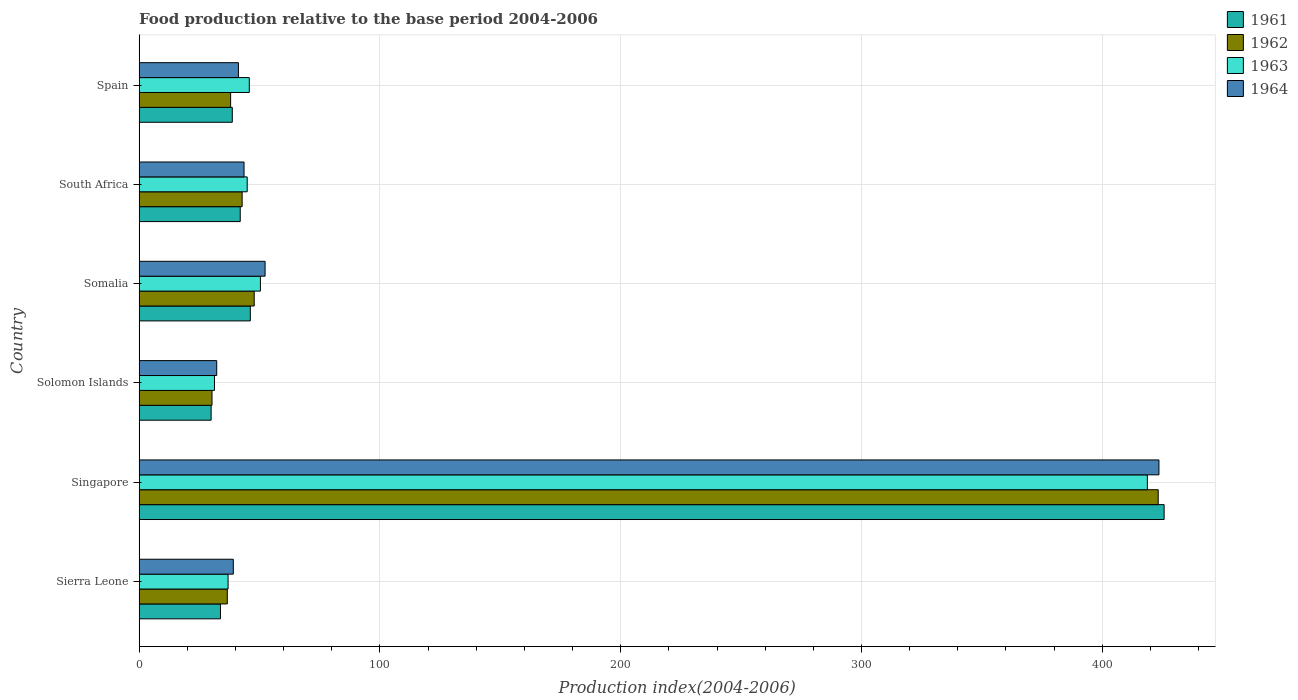How many groups of bars are there?
Provide a succinct answer. 6. How many bars are there on the 1st tick from the top?
Your response must be concise. 4. What is the label of the 3rd group of bars from the top?
Keep it short and to the point. Somalia. What is the food production index in 1964 in Sierra Leone?
Give a very brief answer. 39.1. Across all countries, what is the maximum food production index in 1961?
Make the answer very short. 425.69. Across all countries, what is the minimum food production index in 1963?
Offer a very short reply. 31.28. In which country was the food production index in 1964 maximum?
Your response must be concise. Singapore. In which country was the food production index in 1963 minimum?
Your answer should be very brief. Solomon Islands. What is the total food production index in 1964 in the graph?
Your response must be concise. 631.94. What is the difference between the food production index in 1962 in Sierra Leone and that in South Africa?
Your response must be concise. -6.16. What is the difference between the food production index in 1962 in Sierra Leone and the food production index in 1964 in Solomon Islands?
Keep it short and to the point. 4.4. What is the average food production index in 1963 per country?
Provide a succinct answer. 104.65. What is the difference between the food production index in 1961 and food production index in 1962 in Sierra Leone?
Keep it short and to the point. -2.85. What is the ratio of the food production index in 1963 in Solomon Islands to that in Somalia?
Your answer should be very brief. 0.62. Is the food production index in 1962 in Somalia less than that in South Africa?
Your answer should be compact. No. What is the difference between the highest and the second highest food production index in 1963?
Make the answer very short. 368.37. What is the difference between the highest and the lowest food production index in 1963?
Your answer should be very brief. 387.45. In how many countries, is the food production index in 1962 greater than the average food production index in 1962 taken over all countries?
Ensure brevity in your answer.  1. Is the sum of the food production index in 1964 in Sierra Leone and Solomon Islands greater than the maximum food production index in 1961 across all countries?
Make the answer very short. No. What does the 1st bar from the top in Somalia represents?
Your answer should be very brief. 1964. What does the 3rd bar from the bottom in Spain represents?
Provide a short and direct response. 1963. Is it the case that in every country, the sum of the food production index in 1964 and food production index in 1963 is greater than the food production index in 1961?
Offer a terse response. Yes. Are all the bars in the graph horizontal?
Your response must be concise. Yes. How many countries are there in the graph?
Your answer should be compact. 6. What is the difference between two consecutive major ticks on the X-axis?
Keep it short and to the point. 100. Are the values on the major ticks of X-axis written in scientific E-notation?
Your answer should be compact. No. Does the graph contain any zero values?
Make the answer very short. No. How many legend labels are there?
Make the answer very short. 4. What is the title of the graph?
Provide a short and direct response. Food production relative to the base period 2004-2006. What is the label or title of the X-axis?
Your answer should be very brief. Production index(2004-2006). What is the label or title of the Y-axis?
Give a very brief answer. Country. What is the Production index(2004-2006) of 1961 in Sierra Leone?
Ensure brevity in your answer.  33.76. What is the Production index(2004-2006) in 1962 in Sierra Leone?
Your response must be concise. 36.61. What is the Production index(2004-2006) in 1963 in Sierra Leone?
Provide a succinct answer. 36.93. What is the Production index(2004-2006) in 1964 in Sierra Leone?
Your answer should be compact. 39.1. What is the Production index(2004-2006) in 1961 in Singapore?
Keep it short and to the point. 425.69. What is the Production index(2004-2006) in 1962 in Singapore?
Offer a very short reply. 423.23. What is the Production index(2004-2006) in 1963 in Singapore?
Give a very brief answer. 418.73. What is the Production index(2004-2006) of 1964 in Singapore?
Offer a very short reply. 423.54. What is the Production index(2004-2006) of 1961 in Solomon Islands?
Make the answer very short. 29.89. What is the Production index(2004-2006) of 1962 in Solomon Islands?
Give a very brief answer. 30.26. What is the Production index(2004-2006) in 1963 in Solomon Islands?
Make the answer very short. 31.28. What is the Production index(2004-2006) in 1964 in Solomon Islands?
Your response must be concise. 32.21. What is the Production index(2004-2006) in 1961 in Somalia?
Your response must be concise. 46.17. What is the Production index(2004-2006) in 1962 in Somalia?
Make the answer very short. 47.78. What is the Production index(2004-2006) in 1963 in Somalia?
Make the answer very short. 50.36. What is the Production index(2004-2006) in 1964 in Somalia?
Give a very brief answer. 52.3. What is the Production index(2004-2006) in 1961 in South Africa?
Ensure brevity in your answer.  41.98. What is the Production index(2004-2006) of 1962 in South Africa?
Ensure brevity in your answer.  42.77. What is the Production index(2004-2006) of 1963 in South Africa?
Your response must be concise. 44.87. What is the Production index(2004-2006) of 1964 in South Africa?
Ensure brevity in your answer.  43.56. What is the Production index(2004-2006) of 1961 in Spain?
Your answer should be very brief. 38.68. What is the Production index(2004-2006) in 1962 in Spain?
Provide a short and direct response. 37.99. What is the Production index(2004-2006) in 1963 in Spain?
Ensure brevity in your answer.  45.74. What is the Production index(2004-2006) of 1964 in Spain?
Your answer should be very brief. 41.23. Across all countries, what is the maximum Production index(2004-2006) of 1961?
Provide a succinct answer. 425.69. Across all countries, what is the maximum Production index(2004-2006) in 1962?
Ensure brevity in your answer.  423.23. Across all countries, what is the maximum Production index(2004-2006) in 1963?
Offer a very short reply. 418.73. Across all countries, what is the maximum Production index(2004-2006) in 1964?
Give a very brief answer. 423.54. Across all countries, what is the minimum Production index(2004-2006) in 1961?
Your response must be concise. 29.89. Across all countries, what is the minimum Production index(2004-2006) in 1962?
Your response must be concise. 30.26. Across all countries, what is the minimum Production index(2004-2006) in 1963?
Ensure brevity in your answer.  31.28. Across all countries, what is the minimum Production index(2004-2006) in 1964?
Provide a short and direct response. 32.21. What is the total Production index(2004-2006) of 1961 in the graph?
Give a very brief answer. 616.17. What is the total Production index(2004-2006) in 1962 in the graph?
Offer a very short reply. 618.64. What is the total Production index(2004-2006) of 1963 in the graph?
Your answer should be compact. 627.91. What is the total Production index(2004-2006) of 1964 in the graph?
Give a very brief answer. 631.94. What is the difference between the Production index(2004-2006) of 1961 in Sierra Leone and that in Singapore?
Your answer should be compact. -391.93. What is the difference between the Production index(2004-2006) in 1962 in Sierra Leone and that in Singapore?
Ensure brevity in your answer.  -386.62. What is the difference between the Production index(2004-2006) of 1963 in Sierra Leone and that in Singapore?
Your response must be concise. -381.8. What is the difference between the Production index(2004-2006) in 1964 in Sierra Leone and that in Singapore?
Your response must be concise. -384.44. What is the difference between the Production index(2004-2006) of 1961 in Sierra Leone and that in Solomon Islands?
Provide a succinct answer. 3.87. What is the difference between the Production index(2004-2006) in 1962 in Sierra Leone and that in Solomon Islands?
Your answer should be very brief. 6.35. What is the difference between the Production index(2004-2006) in 1963 in Sierra Leone and that in Solomon Islands?
Offer a terse response. 5.65. What is the difference between the Production index(2004-2006) in 1964 in Sierra Leone and that in Solomon Islands?
Ensure brevity in your answer.  6.89. What is the difference between the Production index(2004-2006) in 1961 in Sierra Leone and that in Somalia?
Give a very brief answer. -12.41. What is the difference between the Production index(2004-2006) of 1962 in Sierra Leone and that in Somalia?
Keep it short and to the point. -11.17. What is the difference between the Production index(2004-2006) in 1963 in Sierra Leone and that in Somalia?
Provide a short and direct response. -13.43. What is the difference between the Production index(2004-2006) in 1964 in Sierra Leone and that in Somalia?
Your response must be concise. -13.2. What is the difference between the Production index(2004-2006) in 1961 in Sierra Leone and that in South Africa?
Your response must be concise. -8.22. What is the difference between the Production index(2004-2006) in 1962 in Sierra Leone and that in South Africa?
Your answer should be compact. -6.16. What is the difference between the Production index(2004-2006) of 1963 in Sierra Leone and that in South Africa?
Give a very brief answer. -7.94. What is the difference between the Production index(2004-2006) of 1964 in Sierra Leone and that in South Africa?
Your response must be concise. -4.46. What is the difference between the Production index(2004-2006) in 1961 in Sierra Leone and that in Spain?
Keep it short and to the point. -4.92. What is the difference between the Production index(2004-2006) of 1962 in Sierra Leone and that in Spain?
Your answer should be compact. -1.38. What is the difference between the Production index(2004-2006) of 1963 in Sierra Leone and that in Spain?
Keep it short and to the point. -8.81. What is the difference between the Production index(2004-2006) in 1964 in Sierra Leone and that in Spain?
Ensure brevity in your answer.  -2.13. What is the difference between the Production index(2004-2006) of 1961 in Singapore and that in Solomon Islands?
Your response must be concise. 395.8. What is the difference between the Production index(2004-2006) of 1962 in Singapore and that in Solomon Islands?
Offer a very short reply. 392.97. What is the difference between the Production index(2004-2006) in 1963 in Singapore and that in Solomon Islands?
Offer a terse response. 387.45. What is the difference between the Production index(2004-2006) of 1964 in Singapore and that in Solomon Islands?
Give a very brief answer. 391.33. What is the difference between the Production index(2004-2006) of 1961 in Singapore and that in Somalia?
Keep it short and to the point. 379.52. What is the difference between the Production index(2004-2006) in 1962 in Singapore and that in Somalia?
Provide a short and direct response. 375.45. What is the difference between the Production index(2004-2006) of 1963 in Singapore and that in Somalia?
Your response must be concise. 368.37. What is the difference between the Production index(2004-2006) of 1964 in Singapore and that in Somalia?
Make the answer very short. 371.24. What is the difference between the Production index(2004-2006) in 1961 in Singapore and that in South Africa?
Keep it short and to the point. 383.71. What is the difference between the Production index(2004-2006) of 1962 in Singapore and that in South Africa?
Offer a very short reply. 380.46. What is the difference between the Production index(2004-2006) in 1963 in Singapore and that in South Africa?
Give a very brief answer. 373.86. What is the difference between the Production index(2004-2006) of 1964 in Singapore and that in South Africa?
Ensure brevity in your answer.  379.98. What is the difference between the Production index(2004-2006) of 1961 in Singapore and that in Spain?
Make the answer very short. 387.01. What is the difference between the Production index(2004-2006) in 1962 in Singapore and that in Spain?
Give a very brief answer. 385.24. What is the difference between the Production index(2004-2006) in 1963 in Singapore and that in Spain?
Ensure brevity in your answer.  372.99. What is the difference between the Production index(2004-2006) in 1964 in Singapore and that in Spain?
Keep it short and to the point. 382.31. What is the difference between the Production index(2004-2006) of 1961 in Solomon Islands and that in Somalia?
Give a very brief answer. -16.28. What is the difference between the Production index(2004-2006) in 1962 in Solomon Islands and that in Somalia?
Provide a succinct answer. -17.52. What is the difference between the Production index(2004-2006) in 1963 in Solomon Islands and that in Somalia?
Your answer should be very brief. -19.08. What is the difference between the Production index(2004-2006) in 1964 in Solomon Islands and that in Somalia?
Give a very brief answer. -20.09. What is the difference between the Production index(2004-2006) of 1961 in Solomon Islands and that in South Africa?
Ensure brevity in your answer.  -12.09. What is the difference between the Production index(2004-2006) in 1962 in Solomon Islands and that in South Africa?
Ensure brevity in your answer.  -12.51. What is the difference between the Production index(2004-2006) of 1963 in Solomon Islands and that in South Africa?
Ensure brevity in your answer.  -13.59. What is the difference between the Production index(2004-2006) in 1964 in Solomon Islands and that in South Africa?
Keep it short and to the point. -11.35. What is the difference between the Production index(2004-2006) in 1961 in Solomon Islands and that in Spain?
Make the answer very short. -8.79. What is the difference between the Production index(2004-2006) of 1962 in Solomon Islands and that in Spain?
Offer a very short reply. -7.73. What is the difference between the Production index(2004-2006) in 1963 in Solomon Islands and that in Spain?
Your answer should be very brief. -14.46. What is the difference between the Production index(2004-2006) of 1964 in Solomon Islands and that in Spain?
Make the answer very short. -9.02. What is the difference between the Production index(2004-2006) of 1961 in Somalia and that in South Africa?
Offer a very short reply. 4.19. What is the difference between the Production index(2004-2006) in 1962 in Somalia and that in South Africa?
Make the answer very short. 5.01. What is the difference between the Production index(2004-2006) in 1963 in Somalia and that in South Africa?
Offer a terse response. 5.49. What is the difference between the Production index(2004-2006) of 1964 in Somalia and that in South Africa?
Offer a very short reply. 8.74. What is the difference between the Production index(2004-2006) of 1961 in Somalia and that in Spain?
Ensure brevity in your answer.  7.49. What is the difference between the Production index(2004-2006) in 1962 in Somalia and that in Spain?
Offer a very short reply. 9.79. What is the difference between the Production index(2004-2006) in 1963 in Somalia and that in Spain?
Give a very brief answer. 4.62. What is the difference between the Production index(2004-2006) in 1964 in Somalia and that in Spain?
Your answer should be compact. 11.07. What is the difference between the Production index(2004-2006) in 1961 in South Africa and that in Spain?
Your response must be concise. 3.3. What is the difference between the Production index(2004-2006) of 1962 in South Africa and that in Spain?
Your answer should be compact. 4.78. What is the difference between the Production index(2004-2006) in 1963 in South Africa and that in Spain?
Offer a terse response. -0.87. What is the difference between the Production index(2004-2006) of 1964 in South Africa and that in Spain?
Ensure brevity in your answer.  2.33. What is the difference between the Production index(2004-2006) in 1961 in Sierra Leone and the Production index(2004-2006) in 1962 in Singapore?
Provide a succinct answer. -389.47. What is the difference between the Production index(2004-2006) of 1961 in Sierra Leone and the Production index(2004-2006) of 1963 in Singapore?
Offer a very short reply. -384.97. What is the difference between the Production index(2004-2006) in 1961 in Sierra Leone and the Production index(2004-2006) in 1964 in Singapore?
Offer a terse response. -389.78. What is the difference between the Production index(2004-2006) in 1962 in Sierra Leone and the Production index(2004-2006) in 1963 in Singapore?
Provide a succinct answer. -382.12. What is the difference between the Production index(2004-2006) of 1962 in Sierra Leone and the Production index(2004-2006) of 1964 in Singapore?
Make the answer very short. -386.93. What is the difference between the Production index(2004-2006) in 1963 in Sierra Leone and the Production index(2004-2006) in 1964 in Singapore?
Your answer should be very brief. -386.61. What is the difference between the Production index(2004-2006) in 1961 in Sierra Leone and the Production index(2004-2006) in 1962 in Solomon Islands?
Your response must be concise. 3.5. What is the difference between the Production index(2004-2006) of 1961 in Sierra Leone and the Production index(2004-2006) of 1963 in Solomon Islands?
Keep it short and to the point. 2.48. What is the difference between the Production index(2004-2006) in 1961 in Sierra Leone and the Production index(2004-2006) in 1964 in Solomon Islands?
Offer a terse response. 1.55. What is the difference between the Production index(2004-2006) in 1962 in Sierra Leone and the Production index(2004-2006) in 1963 in Solomon Islands?
Provide a short and direct response. 5.33. What is the difference between the Production index(2004-2006) in 1963 in Sierra Leone and the Production index(2004-2006) in 1964 in Solomon Islands?
Ensure brevity in your answer.  4.72. What is the difference between the Production index(2004-2006) of 1961 in Sierra Leone and the Production index(2004-2006) of 1962 in Somalia?
Offer a terse response. -14.02. What is the difference between the Production index(2004-2006) of 1961 in Sierra Leone and the Production index(2004-2006) of 1963 in Somalia?
Offer a very short reply. -16.6. What is the difference between the Production index(2004-2006) of 1961 in Sierra Leone and the Production index(2004-2006) of 1964 in Somalia?
Provide a short and direct response. -18.54. What is the difference between the Production index(2004-2006) of 1962 in Sierra Leone and the Production index(2004-2006) of 1963 in Somalia?
Offer a terse response. -13.75. What is the difference between the Production index(2004-2006) of 1962 in Sierra Leone and the Production index(2004-2006) of 1964 in Somalia?
Provide a short and direct response. -15.69. What is the difference between the Production index(2004-2006) in 1963 in Sierra Leone and the Production index(2004-2006) in 1964 in Somalia?
Provide a short and direct response. -15.37. What is the difference between the Production index(2004-2006) of 1961 in Sierra Leone and the Production index(2004-2006) of 1962 in South Africa?
Offer a very short reply. -9.01. What is the difference between the Production index(2004-2006) of 1961 in Sierra Leone and the Production index(2004-2006) of 1963 in South Africa?
Provide a short and direct response. -11.11. What is the difference between the Production index(2004-2006) of 1962 in Sierra Leone and the Production index(2004-2006) of 1963 in South Africa?
Make the answer very short. -8.26. What is the difference between the Production index(2004-2006) of 1962 in Sierra Leone and the Production index(2004-2006) of 1964 in South Africa?
Ensure brevity in your answer.  -6.95. What is the difference between the Production index(2004-2006) in 1963 in Sierra Leone and the Production index(2004-2006) in 1964 in South Africa?
Your answer should be very brief. -6.63. What is the difference between the Production index(2004-2006) in 1961 in Sierra Leone and the Production index(2004-2006) in 1962 in Spain?
Ensure brevity in your answer.  -4.23. What is the difference between the Production index(2004-2006) in 1961 in Sierra Leone and the Production index(2004-2006) in 1963 in Spain?
Make the answer very short. -11.98. What is the difference between the Production index(2004-2006) in 1961 in Sierra Leone and the Production index(2004-2006) in 1964 in Spain?
Make the answer very short. -7.47. What is the difference between the Production index(2004-2006) of 1962 in Sierra Leone and the Production index(2004-2006) of 1963 in Spain?
Your answer should be compact. -9.13. What is the difference between the Production index(2004-2006) of 1962 in Sierra Leone and the Production index(2004-2006) of 1964 in Spain?
Provide a short and direct response. -4.62. What is the difference between the Production index(2004-2006) in 1963 in Sierra Leone and the Production index(2004-2006) in 1964 in Spain?
Provide a short and direct response. -4.3. What is the difference between the Production index(2004-2006) of 1961 in Singapore and the Production index(2004-2006) of 1962 in Solomon Islands?
Make the answer very short. 395.43. What is the difference between the Production index(2004-2006) of 1961 in Singapore and the Production index(2004-2006) of 1963 in Solomon Islands?
Give a very brief answer. 394.41. What is the difference between the Production index(2004-2006) of 1961 in Singapore and the Production index(2004-2006) of 1964 in Solomon Islands?
Keep it short and to the point. 393.48. What is the difference between the Production index(2004-2006) of 1962 in Singapore and the Production index(2004-2006) of 1963 in Solomon Islands?
Make the answer very short. 391.95. What is the difference between the Production index(2004-2006) of 1962 in Singapore and the Production index(2004-2006) of 1964 in Solomon Islands?
Provide a short and direct response. 391.02. What is the difference between the Production index(2004-2006) of 1963 in Singapore and the Production index(2004-2006) of 1964 in Solomon Islands?
Make the answer very short. 386.52. What is the difference between the Production index(2004-2006) in 1961 in Singapore and the Production index(2004-2006) in 1962 in Somalia?
Offer a very short reply. 377.91. What is the difference between the Production index(2004-2006) of 1961 in Singapore and the Production index(2004-2006) of 1963 in Somalia?
Your answer should be very brief. 375.33. What is the difference between the Production index(2004-2006) in 1961 in Singapore and the Production index(2004-2006) in 1964 in Somalia?
Your response must be concise. 373.39. What is the difference between the Production index(2004-2006) in 1962 in Singapore and the Production index(2004-2006) in 1963 in Somalia?
Ensure brevity in your answer.  372.87. What is the difference between the Production index(2004-2006) in 1962 in Singapore and the Production index(2004-2006) in 1964 in Somalia?
Offer a terse response. 370.93. What is the difference between the Production index(2004-2006) in 1963 in Singapore and the Production index(2004-2006) in 1964 in Somalia?
Your response must be concise. 366.43. What is the difference between the Production index(2004-2006) of 1961 in Singapore and the Production index(2004-2006) of 1962 in South Africa?
Provide a succinct answer. 382.92. What is the difference between the Production index(2004-2006) in 1961 in Singapore and the Production index(2004-2006) in 1963 in South Africa?
Your answer should be compact. 380.82. What is the difference between the Production index(2004-2006) in 1961 in Singapore and the Production index(2004-2006) in 1964 in South Africa?
Ensure brevity in your answer.  382.13. What is the difference between the Production index(2004-2006) in 1962 in Singapore and the Production index(2004-2006) in 1963 in South Africa?
Keep it short and to the point. 378.36. What is the difference between the Production index(2004-2006) of 1962 in Singapore and the Production index(2004-2006) of 1964 in South Africa?
Give a very brief answer. 379.67. What is the difference between the Production index(2004-2006) in 1963 in Singapore and the Production index(2004-2006) in 1964 in South Africa?
Give a very brief answer. 375.17. What is the difference between the Production index(2004-2006) in 1961 in Singapore and the Production index(2004-2006) in 1962 in Spain?
Offer a terse response. 387.7. What is the difference between the Production index(2004-2006) of 1961 in Singapore and the Production index(2004-2006) of 1963 in Spain?
Offer a terse response. 379.95. What is the difference between the Production index(2004-2006) of 1961 in Singapore and the Production index(2004-2006) of 1964 in Spain?
Provide a short and direct response. 384.46. What is the difference between the Production index(2004-2006) in 1962 in Singapore and the Production index(2004-2006) in 1963 in Spain?
Provide a short and direct response. 377.49. What is the difference between the Production index(2004-2006) of 1962 in Singapore and the Production index(2004-2006) of 1964 in Spain?
Offer a very short reply. 382. What is the difference between the Production index(2004-2006) in 1963 in Singapore and the Production index(2004-2006) in 1964 in Spain?
Offer a very short reply. 377.5. What is the difference between the Production index(2004-2006) of 1961 in Solomon Islands and the Production index(2004-2006) of 1962 in Somalia?
Provide a succinct answer. -17.89. What is the difference between the Production index(2004-2006) in 1961 in Solomon Islands and the Production index(2004-2006) in 1963 in Somalia?
Your response must be concise. -20.47. What is the difference between the Production index(2004-2006) of 1961 in Solomon Islands and the Production index(2004-2006) of 1964 in Somalia?
Ensure brevity in your answer.  -22.41. What is the difference between the Production index(2004-2006) of 1962 in Solomon Islands and the Production index(2004-2006) of 1963 in Somalia?
Ensure brevity in your answer.  -20.1. What is the difference between the Production index(2004-2006) in 1962 in Solomon Islands and the Production index(2004-2006) in 1964 in Somalia?
Provide a succinct answer. -22.04. What is the difference between the Production index(2004-2006) in 1963 in Solomon Islands and the Production index(2004-2006) in 1964 in Somalia?
Offer a very short reply. -21.02. What is the difference between the Production index(2004-2006) in 1961 in Solomon Islands and the Production index(2004-2006) in 1962 in South Africa?
Ensure brevity in your answer.  -12.88. What is the difference between the Production index(2004-2006) of 1961 in Solomon Islands and the Production index(2004-2006) of 1963 in South Africa?
Offer a very short reply. -14.98. What is the difference between the Production index(2004-2006) of 1961 in Solomon Islands and the Production index(2004-2006) of 1964 in South Africa?
Offer a terse response. -13.67. What is the difference between the Production index(2004-2006) of 1962 in Solomon Islands and the Production index(2004-2006) of 1963 in South Africa?
Your answer should be compact. -14.61. What is the difference between the Production index(2004-2006) of 1963 in Solomon Islands and the Production index(2004-2006) of 1964 in South Africa?
Make the answer very short. -12.28. What is the difference between the Production index(2004-2006) in 1961 in Solomon Islands and the Production index(2004-2006) in 1962 in Spain?
Provide a short and direct response. -8.1. What is the difference between the Production index(2004-2006) in 1961 in Solomon Islands and the Production index(2004-2006) in 1963 in Spain?
Offer a very short reply. -15.85. What is the difference between the Production index(2004-2006) in 1961 in Solomon Islands and the Production index(2004-2006) in 1964 in Spain?
Keep it short and to the point. -11.34. What is the difference between the Production index(2004-2006) in 1962 in Solomon Islands and the Production index(2004-2006) in 1963 in Spain?
Your answer should be very brief. -15.48. What is the difference between the Production index(2004-2006) in 1962 in Solomon Islands and the Production index(2004-2006) in 1964 in Spain?
Your response must be concise. -10.97. What is the difference between the Production index(2004-2006) in 1963 in Solomon Islands and the Production index(2004-2006) in 1964 in Spain?
Provide a succinct answer. -9.95. What is the difference between the Production index(2004-2006) in 1961 in Somalia and the Production index(2004-2006) in 1962 in South Africa?
Ensure brevity in your answer.  3.4. What is the difference between the Production index(2004-2006) in 1961 in Somalia and the Production index(2004-2006) in 1963 in South Africa?
Your answer should be compact. 1.3. What is the difference between the Production index(2004-2006) in 1961 in Somalia and the Production index(2004-2006) in 1964 in South Africa?
Make the answer very short. 2.61. What is the difference between the Production index(2004-2006) of 1962 in Somalia and the Production index(2004-2006) of 1963 in South Africa?
Your answer should be very brief. 2.91. What is the difference between the Production index(2004-2006) of 1962 in Somalia and the Production index(2004-2006) of 1964 in South Africa?
Offer a terse response. 4.22. What is the difference between the Production index(2004-2006) in 1963 in Somalia and the Production index(2004-2006) in 1964 in South Africa?
Offer a terse response. 6.8. What is the difference between the Production index(2004-2006) in 1961 in Somalia and the Production index(2004-2006) in 1962 in Spain?
Your response must be concise. 8.18. What is the difference between the Production index(2004-2006) of 1961 in Somalia and the Production index(2004-2006) of 1963 in Spain?
Offer a very short reply. 0.43. What is the difference between the Production index(2004-2006) of 1961 in Somalia and the Production index(2004-2006) of 1964 in Spain?
Provide a succinct answer. 4.94. What is the difference between the Production index(2004-2006) of 1962 in Somalia and the Production index(2004-2006) of 1963 in Spain?
Provide a succinct answer. 2.04. What is the difference between the Production index(2004-2006) in 1962 in Somalia and the Production index(2004-2006) in 1964 in Spain?
Give a very brief answer. 6.55. What is the difference between the Production index(2004-2006) in 1963 in Somalia and the Production index(2004-2006) in 1964 in Spain?
Offer a terse response. 9.13. What is the difference between the Production index(2004-2006) in 1961 in South Africa and the Production index(2004-2006) in 1962 in Spain?
Keep it short and to the point. 3.99. What is the difference between the Production index(2004-2006) in 1961 in South Africa and the Production index(2004-2006) in 1963 in Spain?
Your answer should be very brief. -3.76. What is the difference between the Production index(2004-2006) in 1962 in South Africa and the Production index(2004-2006) in 1963 in Spain?
Provide a short and direct response. -2.97. What is the difference between the Production index(2004-2006) in 1962 in South Africa and the Production index(2004-2006) in 1964 in Spain?
Offer a terse response. 1.54. What is the difference between the Production index(2004-2006) in 1963 in South Africa and the Production index(2004-2006) in 1964 in Spain?
Offer a very short reply. 3.64. What is the average Production index(2004-2006) in 1961 per country?
Provide a succinct answer. 102.69. What is the average Production index(2004-2006) of 1962 per country?
Make the answer very short. 103.11. What is the average Production index(2004-2006) in 1963 per country?
Your response must be concise. 104.65. What is the average Production index(2004-2006) in 1964 per country?
Ensure brevity in your answer.  105.32. What is the difference between the Production index(2004-2006) in 1961 and Production index(2004-2006) in 1962 in Sierra Leone?
Provide a succinct answer. -2.85. What is the difference between the Production index(2004-2006) of 1961 and Production index(2004-2006) of 1963 in Sierra Leone?
Make the answer very short. -3.17. What is the difference between the Production index(2004-2006) of 1961 and Production index(2004-2006) of 1964 in Sierra Leone?
Provide a short and direct response. -5.34. What is the difference between the Production index(2004-2006) of 1962 and Production index(2004-2006) of 1963 in Sierra Leone?
Keep it short and to the point. -0.32. What is the difference between the Production index(2004-2006) in 1962 and Production index(2004-2006) in 1964 in Sierra Leone?
Give a very brief answer. -2.49. What is the difference between the Production index(2004-2006) of 1963 and Production index(2004-2006) of 1964 in Sierra Leone?
Offer a terse response. -2.17. What is the difference between the Production index(2004-2006) of 1961 and Production index(2004-2006) of 1962 in Singapore?
Make the answer very short. 2.46. What is the difference between the Production index(2004-2006) in 1961 and Production index(2004-2006) in 1963 in Singapore?
Your answer should be compact. 6.96. What is the difference between the Production index(2004-2006) of 1961 and Production index(2004-2006) of 1964 in Singapore?
Provide a succinct answer. 2.15. What is the difference between the Production index(2004-2006) in 1962 and Production index(2004-2006) in 1963 in Singapore?
Keep it short and to the point. 4.5. What is the difference between the Production index(2004-2006) in 1962 and Production index(2004-2006) in 1964 in Singapore?
Provide a succinct answer. -0.31. What is the difference between the Production index(2004-2006) of 1963 and Production index(2004-2006) of 1964 in Singapore?
Keep it short and to the point. -4.81. What is the difference between the Production index(2004-2006) in 1961 and Production index(2004-2006) in 1962 in Solomon Islands?
Give a very brief answer. -0.37. What is the difference between the Production index(2004-2006) of 1961 and Production index(2004-2006) of 1963 in Solomon Islands?
Your answer should be very brief. -1.39. What is the difference between the Production index(2004-2006) in 1961 and Production index(2004-2006) in 1964 in Solomon Islands?
Give a very brief answer. -2.32. What is the difference between the Production index(2004-2006) in 1962 and Production index(2004-2006) in 1963 in Solomon Islands?
Your answer should be compact. -1.02. What is the difference between the Production index(2004-2006) in 1962 and Production index(2004-2006) in 1964 in Solomon Islands?
Your response must be concise. -1.95. What is the difference between the Production index(2004-2006) of 1963 and Production index(2004-2006) of 1964 in Solomon Islands?
Ensure brevity in your answer.  -0.93. What is the difference between the Production index(2004-2006) in 1961 and Production index(2004-2006) in 1962 in Somalia?
Offer a very short reply. -1.61. What is the difference between the Production index(2004-2006) in 1961 and Production index(2004-2006) in 1963 in Somalia?
Your answer should be very brief. -4.19. What is the difference between the Production index(2004-2006) of 1961 and Production index(2004-2006) of 1964 in Somalia?
Make the answer very short. -6.13. What is the difference between the Production index(2004-2006) in 1962 and Production index(2004-2006) in 1963 in Somalia?
Make the answer very short. -2.58. What is the difference between the Production index(2004-2006) in 1962 and Production index(2004-2006) in 1964 in Somalia?
Give a very brief answer. -4.52. What is the difference between the Production index(2004-2006) in 1963 and Production index(2004-2006) in 1964 in Somalia?
Make the answer very short. -1.94. What is the difference between the Production index(2004-2006) in 1961 and Production index(2004-2006) in 1962 in South Africa?
Ensure brevity in your answer.  -0.79. What is the difference between the Production index(2004-2006) in 1961 and Production index(2004-2006) in 1963 in South Africa?
Give a very brief answer. -2.89. What is the difference between the Production index(2004-2006) in 1961 and Production index(2004-2006) in 1964 in South Africa?
Provide a short and direct response. -1.58. What is the difference between the Production index(2004-2006) in 1962 and Production index(2004-2006) in 1963 in South Africa?
Make the answer very short. -2.1. What is the difference between the Production index(2004-2006) of 1962 and Production index(2004-2006) of 1964 in South Africa?
Your response must be concise. -0.79. What is the difference between the Production index(2004-2006) of 1963 and Production index(2004-2006) of 1964 in South Africa?
Offer a very short reply. 1.31. What is the difference between the Production index(2004-2006) in 1961 and Production index(2004-2006) in 1962 in Spain?
Provide a succinct answer. 0.69. What is the difference between the Production index(2004-2006) in 1961 and Production index(2004-2006) in 1963 in Spain?
Your answer should be very brief. -7.06. What is the difference between the Production index(2004-2006) in 1961 and Production index(2004-2006) in 1964 in Spain?
Provide a short and direct response. -2.55. What is the difference between the Production index(2004-2006) in 1962 and Production index(2004-2006) in 1963 in Spain?
Provide a short and direct response. -7.75. What is the difference between the Production index(2004-2006) in 1962 and Production index(2004-2006) in 1964 in Spain?
Your answer should be compact. -3.24. What is the difference between the Production index(2004-2006) of 1963 and Production index(2004-2006) of 1964 in Spain?
Make the answer very short. 4.51. What is the ratio of the Production index(2004-2006) of 1961 in Sierra Leone to that in Singapore?
Your answer should be very brief. 0.08. What is the ratio of the Production index(2004-2006) in 1962 in Sierra Leone to that in Singapore?
Provide a short and direct response. 0.09. What is the ratio of the Production index(2004-2006) of 1963 in Sierra Leone to that in Singapore?
Your response must be concise. 0.09. What is the ratio of the Production index(2004-2006) of 1964 in Sierra Leone to that in Singapore?
Your answer should be very brief. 0.09. What is the ratio of the Production index(2004-2006) of 1961 in Sierra Leone to that in Solomon Islands?
Give a very brief answer. 1.13. What is the ratio of the Production index(2004-2006) of 1962 in Sierra Leone to that in Solomon Islands?
Offer a very short reply. 1.21. What is the ratio of the Production index(2004-2006) in 1963 in Sierra Leone to that in Solomon Islands?
Your answer should be compact. 1.18. What is the ratio of the Production index(2004-2006) in 1964 in Sierra Leone to that in Solomon Islands?
Offer a very short reply. 1.21. What is the ratio of the Production index(2004-2006) of 1961 in Sierra Leone to that in Somalia?
Ensure brevity in your answer.  0.73. What is the ratio of the Production index(2004-2006) in 1962 in Sierra Leone to that in Somalia?
Give a very brief answer. 0.77. What is the ratio of the Production index(2004-2006) of 1963 in Sierra Leone to that in Somalia?
Your answer should be very brief. 0.73. What is the ratio of the Production index(2004-2006) in 1964 in Sierra Leone to that in Somalia?
Offer a terse response. 0.75. What is the ratio of the Production index(2004-2006) in 1961 in Sierra Leone to that in South Africa?
Keep it short and to the point. 0.8. What is the ratio of the Production index(2004-2006) in 1962 in Sierra Leone to that in South Africa?
Your response must be concise. 0.86. What is the ratio of the Production index(2004-2006) in 1963 in Sierra Leone to that in South Africa?
Offer a terse response. 0.82. What is the ratio of the Production index(2004-2006) of 1964 in Sierra Leone to that in South Africa?
Keep it short and to the point. 0.9. What is the ratio of the Production index(2004-2006) of 1961 in Sierra Leone to that in Spain?
Provide a short and direct response. 0.87. What is the ratio of the Production index(2004-2006) in 1962 in Sierra Leone to that in Spain?
Provide a succinct answer. 0.96. What is the ratio of the Production index(2004-2006) of 1963 in Sierra Leone to that in Spain?
Give a very brief answer. 0.81. What is the ratio of the Production index(2004-2006) of 1964 in Sierra Leone to that in Spain?
Your response must be concise. 0.95. What is the ratio of the Production index(2004-2006) in 1961 in Singapore to that in Solomon Islands?
Keep it short and to the point. 14.24. What is the ratio of the Production index(2004-2006) of 1962 in Singapore to that in Solomon Islands?
Offer a terse response. 13.99. What is the ratio of the Production index(2004-2006) in 1963 in Singapore to that in Solomon Islands?
Ensure brevity in your answer.  13.39. What is the ratio of the Production index(2004-2006) in 1964 in Singapore to that in Solomon Islands?
Keep it short and to the point. 13.15. What is the ratio of the Production index(2004-2006) in 1961 in Singapore to that in Somalia?
Your answer should be very brief. 9.22. What is the ratio of the Production index(2004-2006) of 1962 in Singapore to that in Somalia?
Provide a short and direct response. 8.86. What is the ratio of the Production index(2004-2006) in 1963 in Singapore to that in Somalia?
Offer a very short reply. 8.31. What is the ratio of the Production index(2004-2006) in 1964 in Singapore to that in Somalia?
Your answer should be compact. 8.1. What is the ratio of the Production index(2004-2006) of 1961 in Singapore to that in South Africa?
Give a very brief answer. 10.14. What is the ratio of the Production index(2004-2006) of 1962 in Singapore to that in South Africa?
Keep it short and to the point. 9.9. What is the ratio of the Production index(2004-2006) in 1963 in Singapore to that in South Africa?
Your answer should be compact. 9.33. What is the ratio of the Production index(2004-2006) of 1964 in Singapore to that in South Africa?
Make the answer very short. 9.72. What is the ratio of the Production index(2004-2006) of 1961 in Singapore to that in Spain?
Make the answer very short. 11.01. What is the ratio of the Production index(2004-2006) of 1962 in Singapore to that in Spain?
Make the answer very short. 11.14. What is the ratio of the Production index(2004-2006) in 1963 in Singapore to that in Spain?
Offer a very short reply. 9.15. What is the ratio of the Production index(2004-2006) of 1964 in Singapore to that in Spain?
Your answer should be very brief. 10.27. What is the ratio of the Production index(2004-2006) of 1961 in Solomon Islands to that in Somalia?
Offer a terse response. 0.65. What is the ratio of the Production index(2004-2006) of 1962 in Solomon Islands to that in Somalia?
Your answer should be very brief. 0.63. What is the ratio of the Production index(2004-2006) of 1963 in Solomon Islands to that in Somalia?
Keep it short and to the point. 0.62. What is the ratio of the Production index(2004-2006) of 1964 in Solomon Islands to that in Somalia?
Your answer should be very brief. 0.62. What is the ratio of the Production index(2004-2006) of 1961 in Solomon Islands to that in South Africa?
Provide a short and direct response. 0.71. What is the ratio of the Production index(2004-2006) of 1962 in Solomon Islands to that in South Africa?
Provide a succinct answer. 0.71. What is the ratio of the Production index(2004-2006) in 1963 in Solomon Islands to that in South Africa?
Offer a very short reply. 0.7. What is the ratio of the Production index(2004-2006) in 1964 in Solomon Islands to that in South Africa?
Give a very brief answer. 0.74. What is the ratio of the Production index(2004-2006) in 1961 in Solomon Islands to that in Spain?
Your response must be concise. 0.77. What is the ratio of the Production index(2004-2006) in 1962 in Solomon Islands to that in Spain?
Offer a very short reply. 0.8. What is the ratio of the Production index(2004-2006) in 1963 in Solomon Islands to that in Spain?
Offer a terse response. 0.68. What is the ratio of the Production index(2004-2006) in 1964 in Solomon Islands to that in Spain?
Give a very brief answer. 0.78. What is the ratio of the Production index(2004-2006) in 1961 in Somalia to that in South Africa?
Offer a very short reply. 1.1. What is the ratio of the Production index(2004-2006) of 1962 in Somalia to that in South Africa?
Your response must be concise. 1.12. What is the ratio of the Production index(2004-2006) of 1963 in Somalia to that in South Africa?
Provide a short and direct response. 1.12. What is the ratio of the Production index(2004-2006) of 1964 in Somalia to that in South Africa?
Your answer should be compact. 1.2. What is the ratio of the Production index(2004-2006) of 1961 in Somalia to that in Spain?
Your answer should be compact. 1.19. What is the ratio of the Production index(2004-2006) of 1962 in Somalia to that in Spain?
Keep it short and to the point. 1.26. What is the ratio of the Production index(2004-2006) of 1963 in Somalia to that in Spain?
Keep it short and to the point. 1.1. What is the ratio of the Production index(2004-2006) of 1964 in Somalia to that in Spain?
Your response must be concise. 1.27. What is the ratio of the Production index(2004-2006) in 1961 in South Africa to that in Spain?
Provide a short and direct response. 1.09. What is the ratio of the Production index(2004-2006) of 1962 in South Africa to that in Spain?
Offer a terse response. 1.13. What is the ratio of the Production index(2004-2006) of 1963 in South Africa to that in Spain?
Your answer should be very brief. 0.98. What is the ratio of the Production index(2004-2006) in 1964 in South Africa to that in Spain?
Your response must be concise. 1.06. What is the difference between the highest and the second highest Production index(2004-2006) in 1961?
Give a very brief answer. 379.52. What is the difference between the highest and the second highest Production index(2004-2006) in 1962?
Offer a very short reply. 375.45. What is the difference between the highest and the second highest Production index(2004-2006) in 1963?
Keep it short and to the point. 368.37. What is the difference between the highest and the second highest Production index(2004-2006) in 1964?
Offer a terse response. 371.24. What is the difference between the highest and the lowest Production index(2004-2006) of 1961?
Offer a terse response. 395.8. What is the difference between the highest and the lowest Production index(2004-2006) in 1962?
Your answer should be compact. 392.97. What is the difference between the highest and the lowest Production index(2004-2006) in 1963?
Your answer should be compact. 387.45. What is the difference between the highest and the lowest Production index(2004-2006) in 1964?
Offer a very short reply. 391.33. 